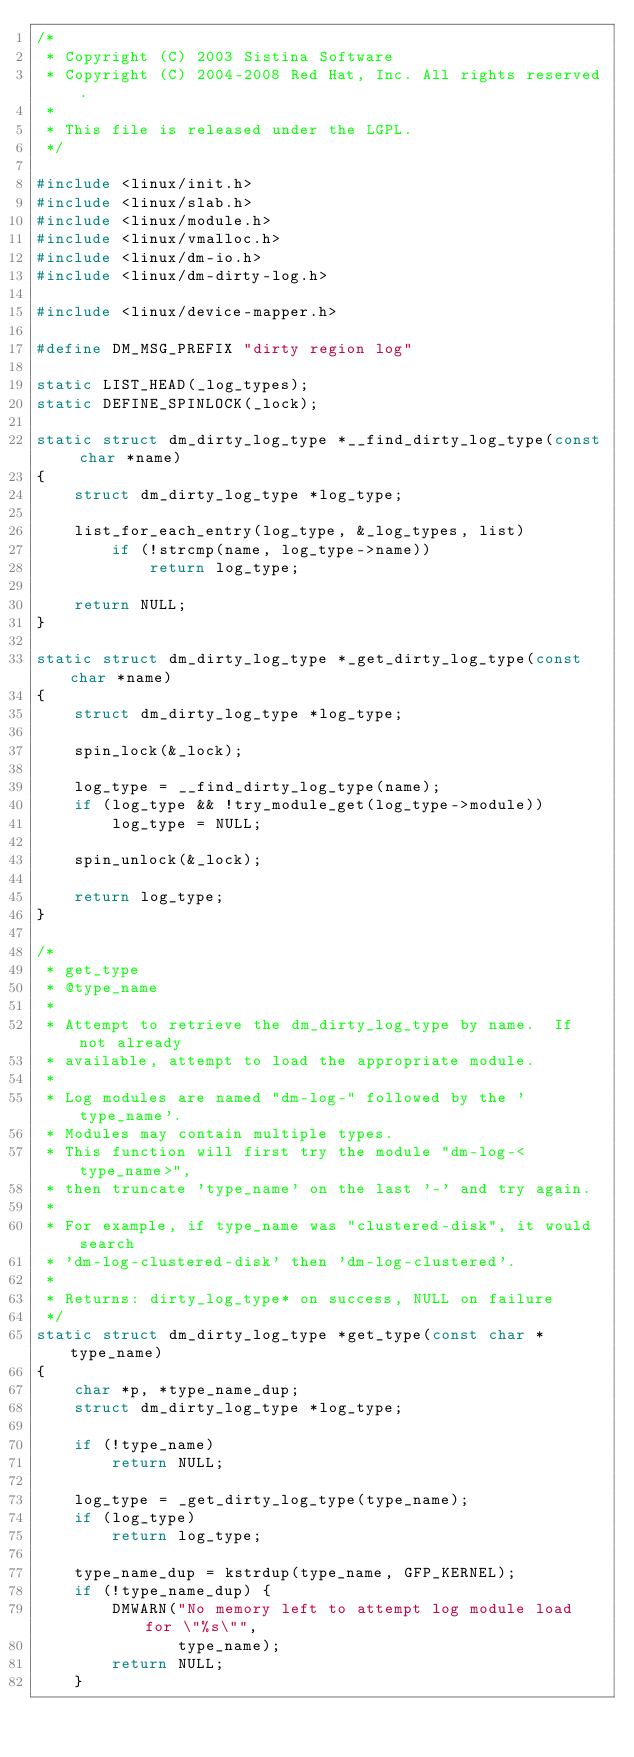Convert code to text. <code><loc_0><loc_0><loc_500><loc_500><_C_>/*
 * Copyright (C) 2003 Sistina Software
 * Copyright (C) 2004-2008 Red Hat, Inc. All rights reserved.
 *
 * This file is released under the LGPL.
 */

#include <linux/init.h>
#include <linux/slab.h>
#include <linux/module.h>
#include <linux/vmalloc.h>
#include <linux/dm-io.h>
#include <linux/dm-dirty-log.h>

#include <linux/device-mapper.h>

#define DM_MSG_PREFIX "dirty region log"

static LIST_HEAD(_log_types);
static DEFINE_SPINLOCK(_lock);

static struct dm_dirty_log_type *__find_dirty_log_type(const char *name)
{
	struct dm_dirty_log_type *log_type;

	list_for_each_entry(log_type, &_log_types, list)
		if (!strcmp(name, log_type->name))
			return log_type;

	return NULL;
}

static struct dm_dirty_log_type *_get_dirty_log_type(const char *name)
{
	struct dm_dirty_log_type *log_type;

	spin_lock(&_lock);

	log_type = __find_dirty_log_type(name);
	if (log_type && !try_module_get(log_type->module))
		log_type = NULL;

	spin_unlock(&_lock);

	return log_type;
}

/*
 * get_type
 * @type_name
 *
 * Attempt to retrieve the dm_dirty_log_type by name.  If not already
 * available, attempt to load the appropriate module.
 *
 * Log modules are named "dm-log-" followed by the 'type_name'.
 * Modules may contain multiple types.
 * This function will first try the module "dm-log-<type_name>",
 * then truncate 'type_name' on the last '-' and try again.
 *
 * For example, if type_name was "clustered-disk", it would search
 * 'dm-log-clustered-disk' then 'dm-log-clustered'.
 *
 * Returns: dirty_log_type* on success, NULL on failure
 */
static struct dm_dirty_log_type *get_type(const char *type_name)
{
	char *p, *type_name_dup;
	struct dm_dirty_log_type *log_type;

	if (!type_name)
		return NULL;

	log_type = _get_dirty_log_type(type_name);
	if (log_type)
		return log_type;

	type_name_dup = kstrdup(type_name, GFP_KERNEL);
	if (!type_name_dup) {
		DMWARN("No memory left to attempt log module load for \"%s\"",
		       type_name);
		return NULL;
	}
</code> 